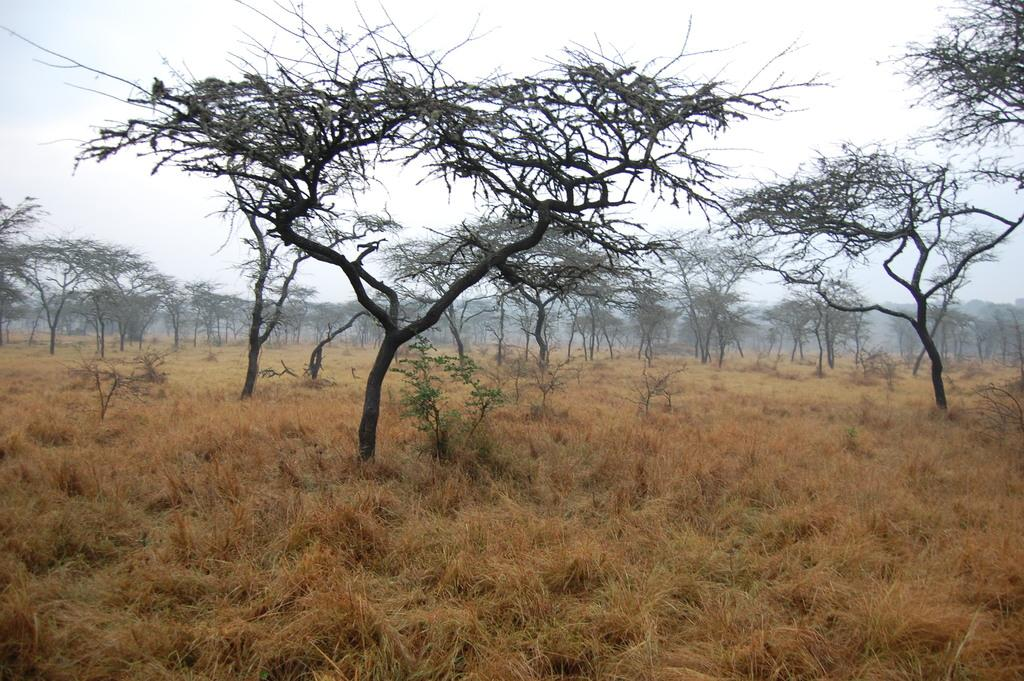What type of vegetation can be seen in the image? There is grass in the image. What other natural elements are present in the image? There are many trees present in the image. What is the condition of the sky in the image? The sky is clear in the image. What type of pollution can be seen in the image? There is no pollution present in the image; it features grass, trees, and a clear sky. How many cars are visible in the image? There are no cars present in the image. 